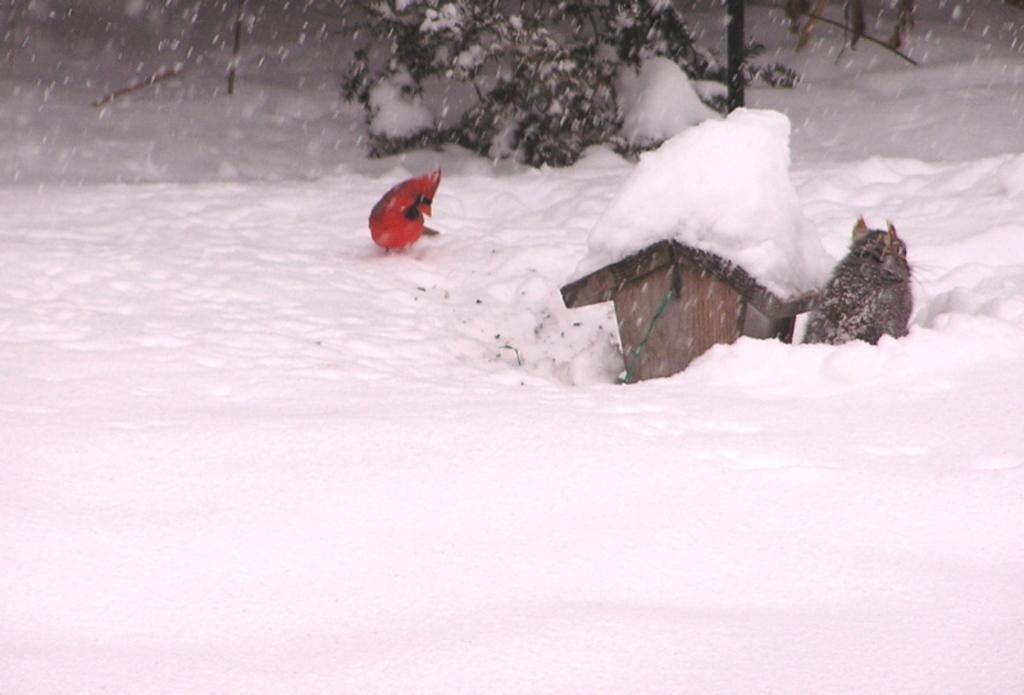Can you describe this image briefly? In this picture I can see a bird, cat and a bird house on the snow, and in the background there is a plant. 